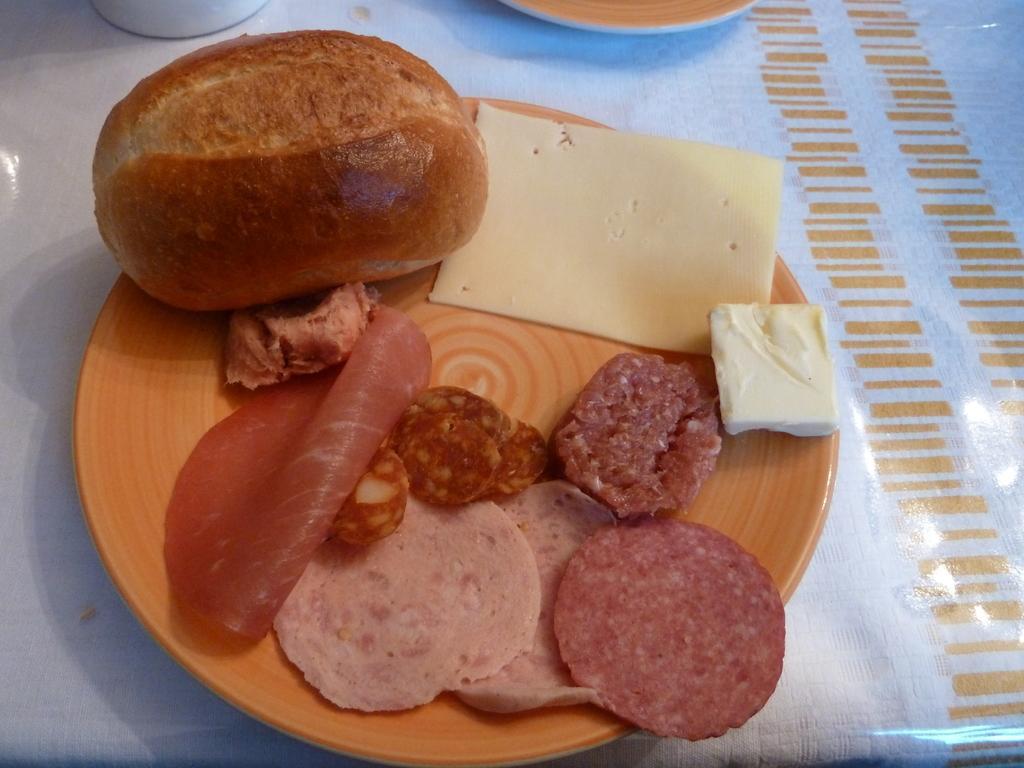Could you give a brief overview of what you see in this image? In this image we can see a plate containing food is placed on the surface. At the top of the image we can see a plate and a bowl. 